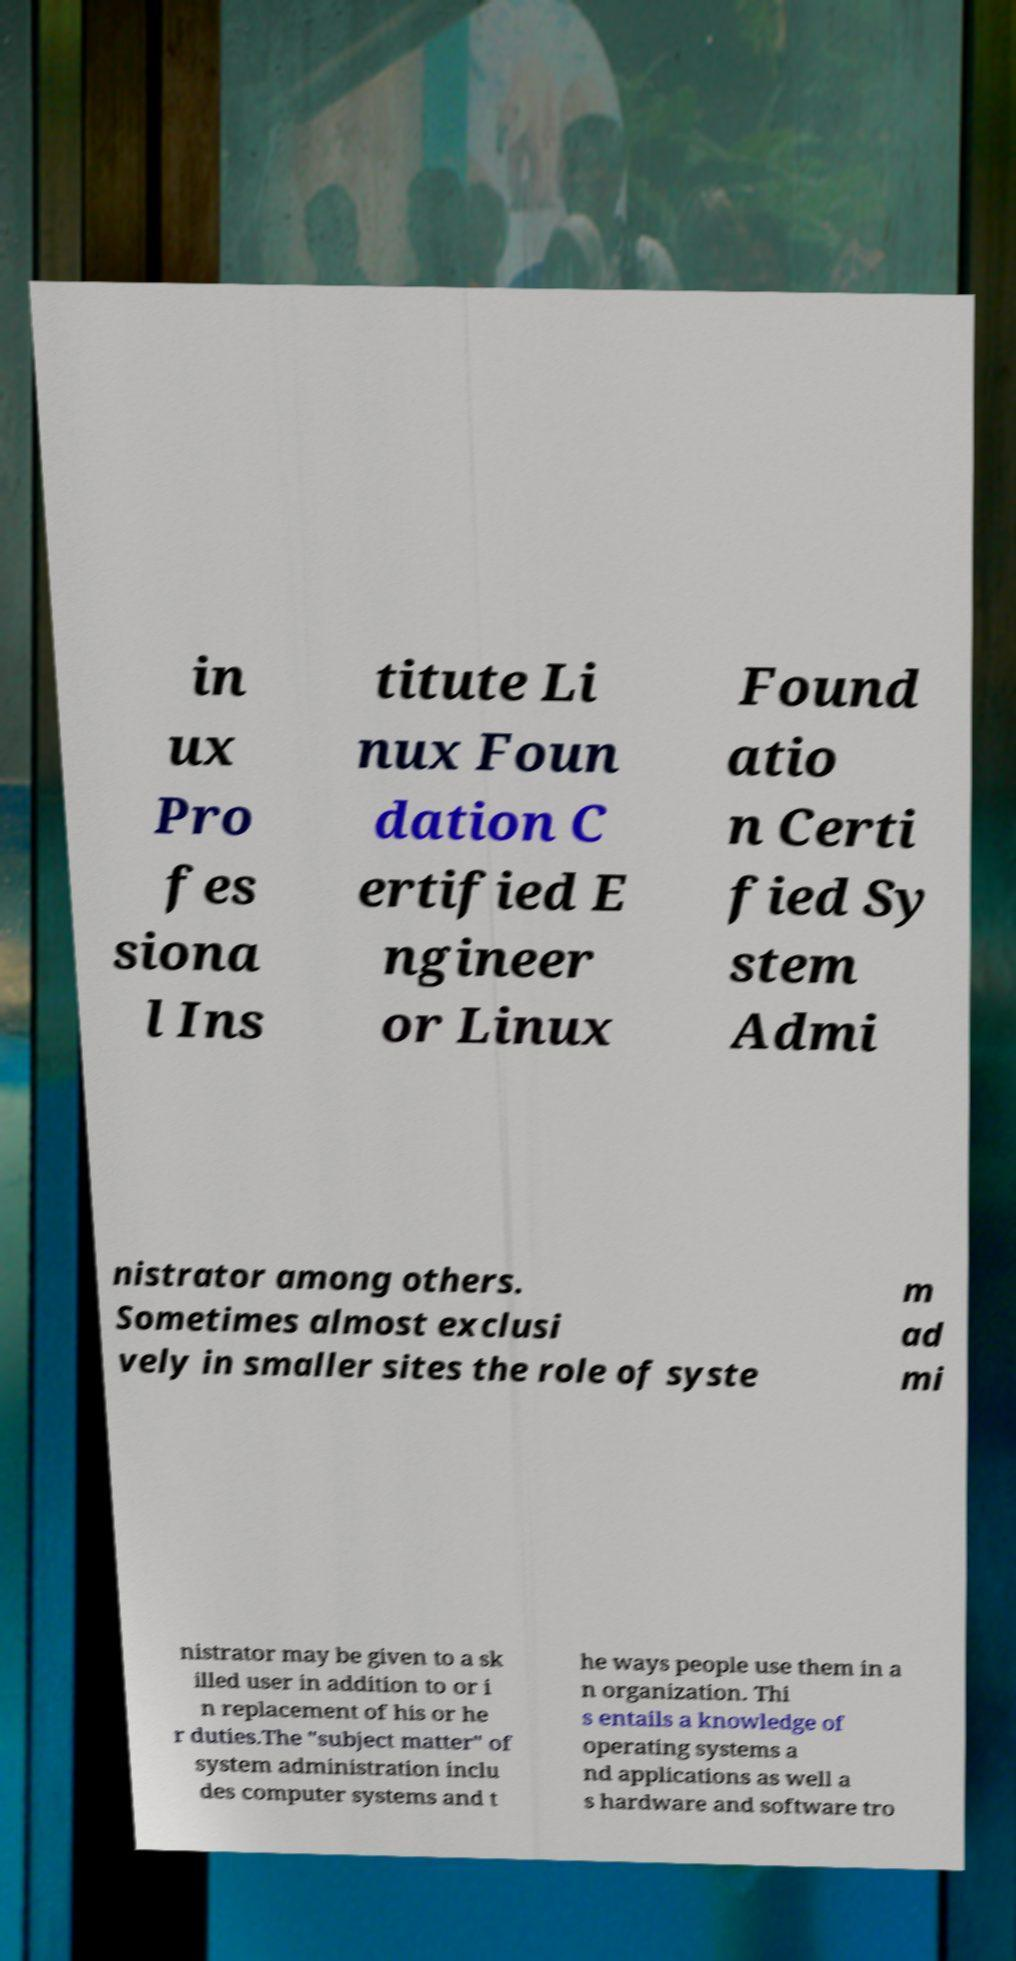I need the written content from this picture converted into text. Can you do that? in ux Pro fes siona l Ins titute Li nux Foun dation C ertified E ngineer or Linux Found atio n Certi fied Sy stem Admi nistrator among others. Sometimes almost exclusi vely in smaller sites the role of syste m ad mi nistrator may be given to a sk illed user in addition to or i n replacement of his or he r duties.The "subject matter" of system administration inclu des computer systems and t he ways people use them in a n organization. Thi s entails a knowledge of operating systems a nd applications as well a s hardware and software tro 